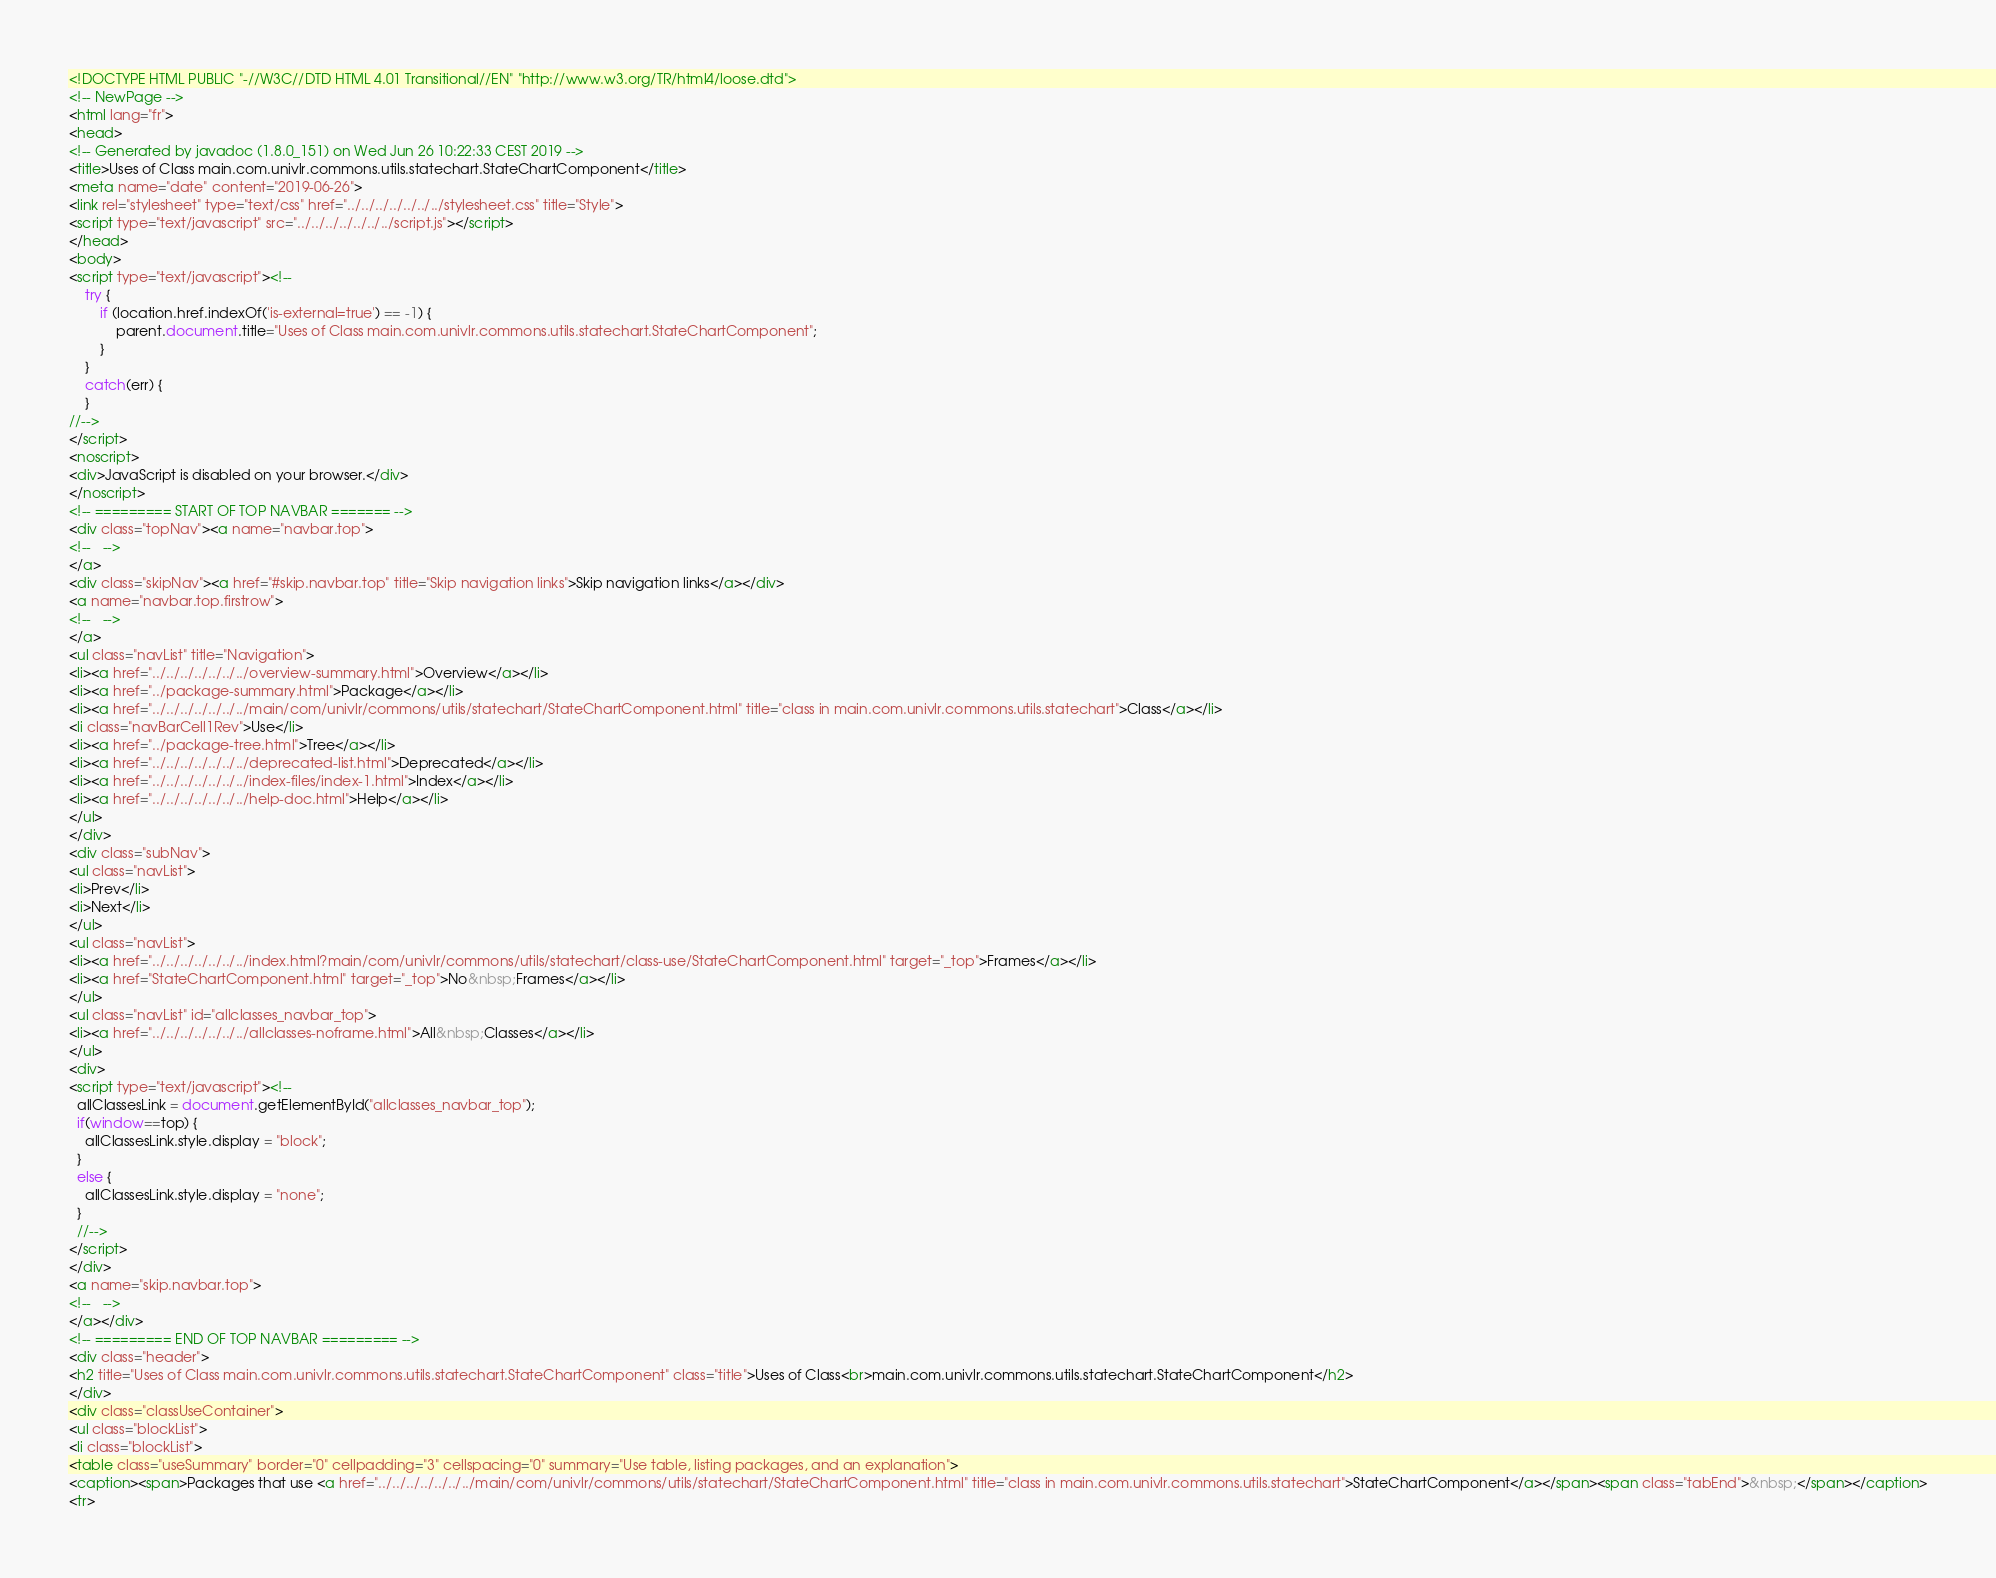<code> <loc_0><loc_0><loc_500><loc_500><_HTML_><!DOCTYPE HTML PUBLIC "-//W3C//DTD HTML 4.01 Transitional//EN" "http://www.w3.org/TR/html4/loose.dtd">
<!-- NewPage -->
<html lang="fr">
<head>
<!-- Generated by javadoc (1.8.0_151) on Wed Jun 26 10:22:33 CEST 2019 -->
<title>Uses of Class main.com.univlr.commons.utils.statechart.StateChartComponent</title>
<meta name="date" content="2019-06-26">
<link rel="stylesheet" type="text/css" href="../../../../../../../stylesheet.css" title="Style">
<script type="text/javascript" src="../../../../../../../script.js"></script>
</head>
<body>
<script type="text/javascript"><!--
    try {
        if (location.href.indexOf('is-external=true') == -1) {
            parent.document.title="Uses of Class main.com.univlr.commons.utils.statechart.StateChartComponent";
        }
    }
    catch(err) {
    }
//-->
</script>
<noscript>
<div>JavaScript is disabled on your browser.</div>
</noscript>
<!-- ========= START OF TOP NAVBAR ======= -->
<div class="topNav"><a name="navbar.top">
<!--   -->
</a>
<div class="skipNav"><a href="#skip.navbar.top" title="Skip navigation links">Skip navigation links</a></div>
<a name="navbar.top.firstrow">
<!--   -->
</a>
<ul class="navList" title="Navigation">
<li><a href="../../../../../../../overview-summary.html">Overview</a></li>
<li><a href="../package-summary.html">Package</a></li>
<li><a href="../../../../../../../main/com/univlr/commons/utils/statechart/StateChartComponent.html" title="class in main.com.univlr.commons.utils.statechart">Class</a></li>
<li class="navBarCell1Rev">Use</li>
<li><a href="../package-tree.html">Tree</a></li>
<li><a href="../../../../../../../deprecated-list.html">Deprecated</a></li>
<li><a href="../../../../../../../index-files/index-1.html">Index</a></li>
<li><a href="../../../../../../../help-doc.html">Help</a></li>
</ul>
</div>
<div class="subNav">
<ul class="navList">
<li>Prev</li>
<li>Next</li>
</ul>
<ul class="navList">
<li><a href="../../../../../../../index.html?main/com/univlr/commons/utils/statechart/class-use/StateChartComponent.html" target="_top">Frames</a></li>
<li><a href="StateChartComponent.html" target="_top">No&nbsp;Frames</a></li>
</ul>
<ul class="navList" id="allclasses_navbar_top">
<li><a href="../../../../../../../allclasses-noframe.html">All&nbsp;Classes</a></li>
</ul>
<div>
<script type="text/javascript"><!--
  allClassesLink = document.getElementById("allclasses_navbar_top");
  if(window==top) {
    allClassesLink.style.display = "block";
  }
  else {
    allClassesLink.style.display = "none";
  }
  //-->
</script>
</div>
<a name="skip.navbar.top">
<!--   -->
</a></div>
<!-- ========= END OF TOP NAVBAR ========= -->
<div class="header">
<h2 title="Uses of Class main.com.univlr.commons.utils.statechart.StateChartComponent" class="title">Uses of Class<br>main.com.univlr.commons.utils.statechart.StateChartComponent</h2>
</div>
<div class="classUseContainer">
<ul class="blockList">
<li class="blockList">
<table class="useSummary" border="0" cellpadding="3" cellspacing="0" summary="Use table, listing packages, and an explanation">
<caption><span>Packages that use <a href="../../../../../../../main/com/univlr/commons/utils/statechart/StateChartComponent.html" title="class in main.com.univlr.commons.utils.statechart">StateChartComponent</a></span><span class="tabEnd">&nbsp;</span></caption>
<tr></code> 